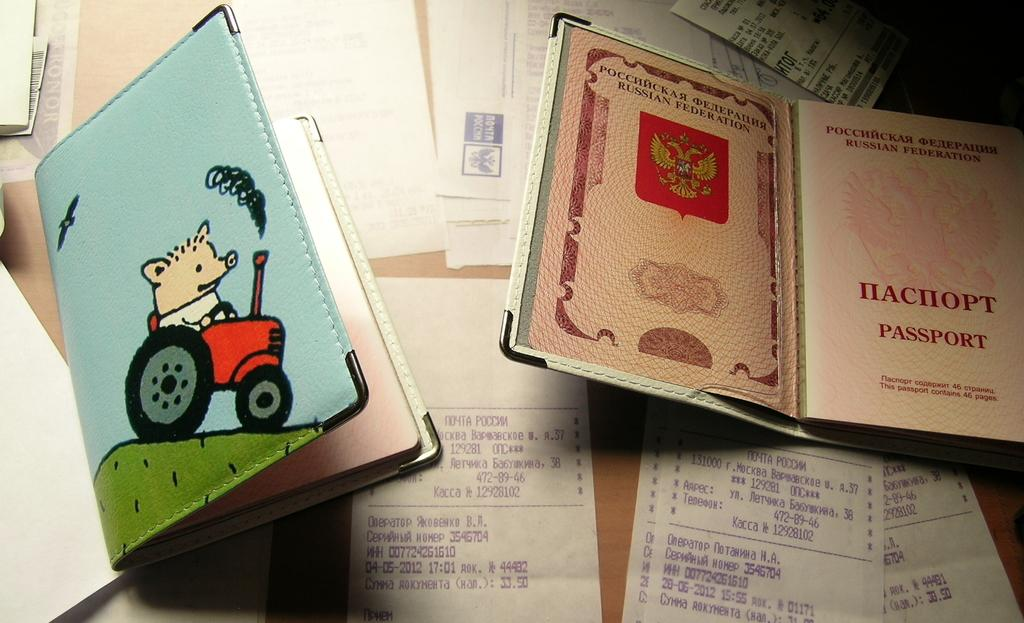<image>
Summarize the visual content of the image. On a table or desk are some receipts, papers, and what appears to be a Russian Federation PASSPORT. 